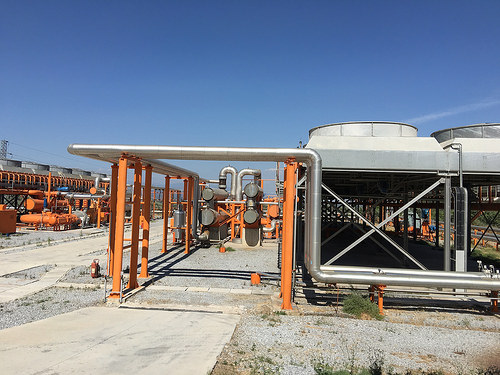<image>
Is the pipe behind the ground? No. The pipe is not behind the ground. From this viewpoint, the pipe appears to be positioned elsewhere in the scene. 